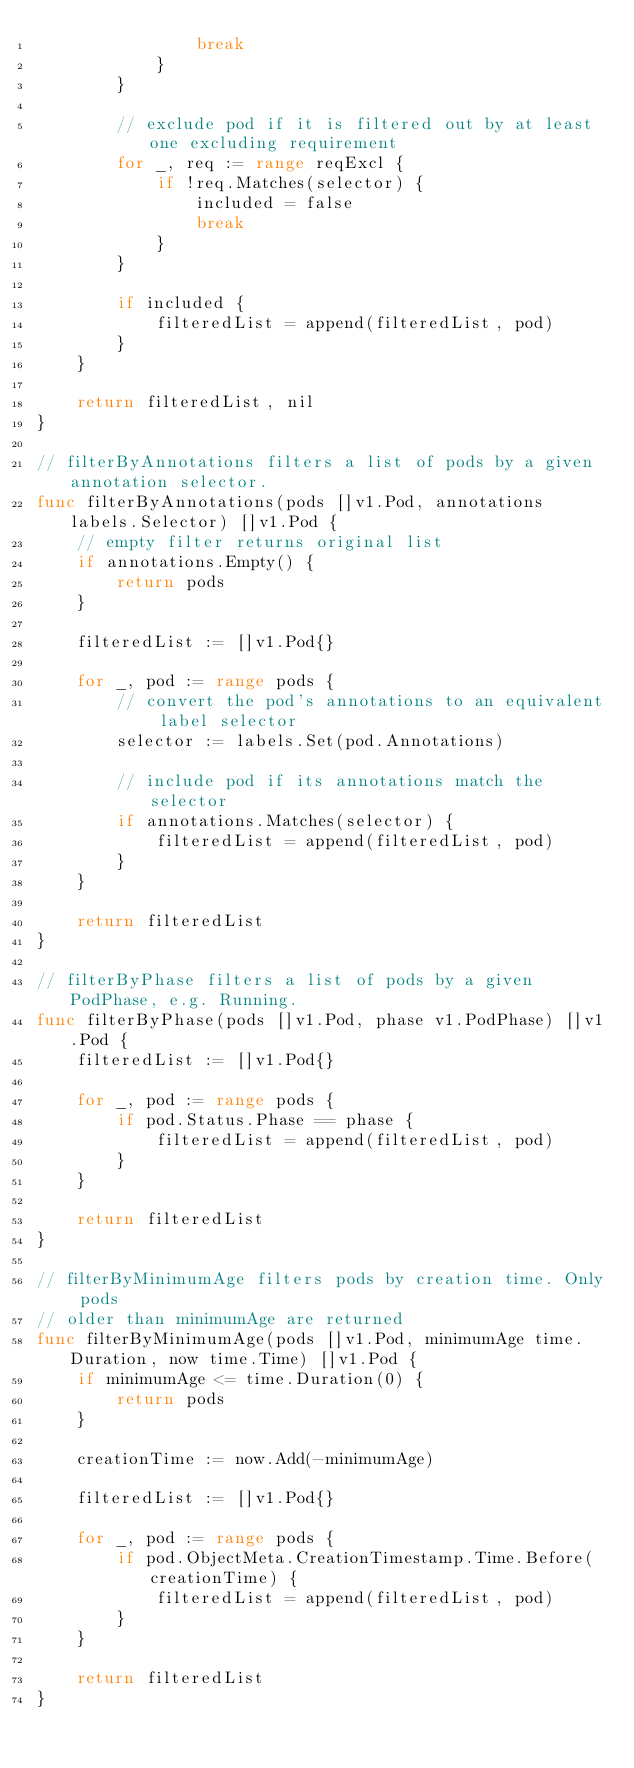<code> <loc_0><loc_0><loc_500><loc_500><_Go_>				break
			}
		}

		// exclude pod if it is filtered out by at least one excluding requirement
		for _, req := range reqExcl {
			if !req.Matches(selector) {
				included = false
				break
			}
		}

		if included {
			filteredList = append(filteredList, pod)
		}
	}

	return filteredList, nil
}

// filterByAnnotations filters a list of pods by a given annotation selector.
func filterByAnnotations(pods []v1.Pod, annotations labels.Selector) []v1.Pod {
	// empty filter returns original list
	if annotations.Empty() {
		return pods
	}

	filteredList := []v1.Pod{}

	for _, pod := range pods {
		// convert the pod's annotations to an equivalent label selector
		selector := labels.Set(pod.Annotations)

		// include pod if its annotations match the selector
		if annotations.Matches(selector) {
			filteredList = append(filteredList, pod)
		}
	}

	return filteredList
}

// filterByPhase filters a list of pods by a given PodPhase, e.g. Running.
func filterByPhase(pods []v1.Pod, phase v1.PodPhase) []v1.Pod {
	filteredList := []v1.Pod{}

	for _, pod := range pods {
		if pod.Status.Phase == phase {
			filteredList = append(filteredList, pod)
		}
	}

	return filteredList
}

// filterByMinimumAge filters pods by creation time. Only pods
// older than minimumAge are returned
func filterByMinimumAge(pods []v1.Pod, minimumAge time.Duration, now time.Time) []v1.Pod {
	if minimumAge <= time.Duration(0) {
		return pods
	}

	creationTime := now.Add(-minimumAge)

	filteredList := []v1.Pod{}

	for _, pod := range pods {
		if pod.ObjectMeta.CreationTimestamp.Time.Before(creationTime) {
			filteredList = append(filteredList, pod)
		}
	}

	return filteredList
}
</code> 